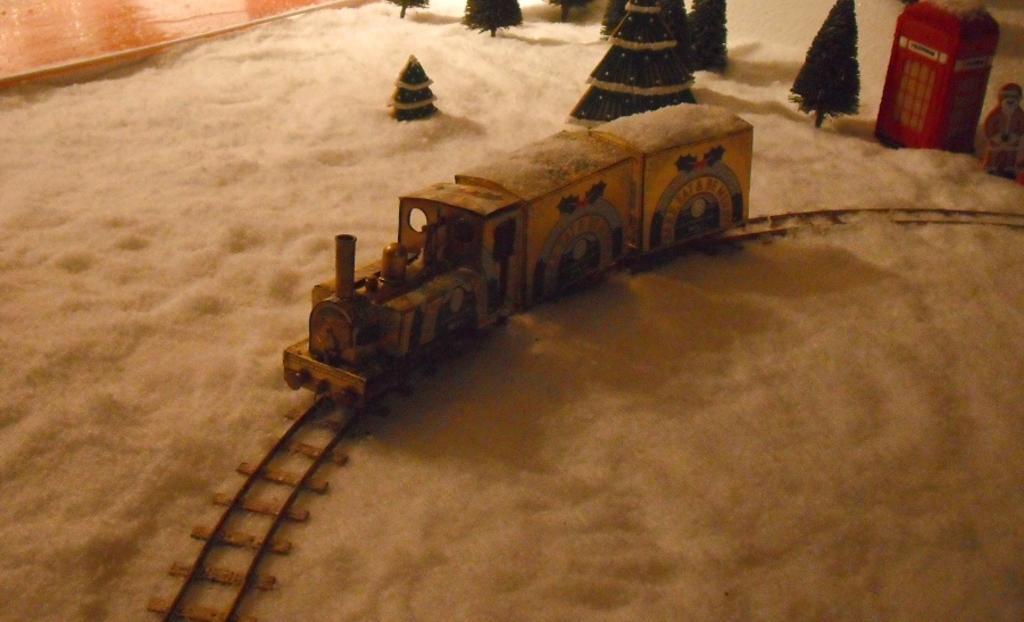Can you describe this image briefly? In the foreground of this image, there is a toy train on the track. We can also see white sand, depicted trees and a depicted person on the sand. At the top left, it seems like there is a wooden surface. 